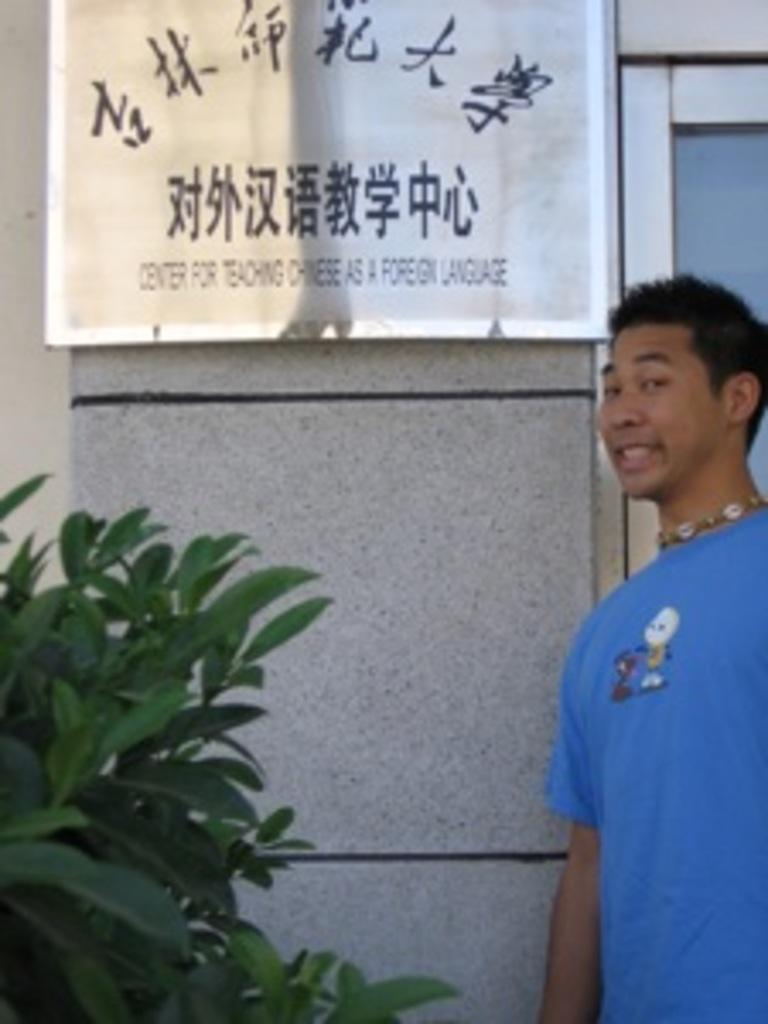What is the man in the image doing? The man is standing in the image and smiling. What can be seen in the background of the image? There are leaves visible in the image. What is on the wall in the image? There is a name board on the wall in the image. What type of cactus can be seen being destroyed in the image? There is no cactus or destruction present in the image. 